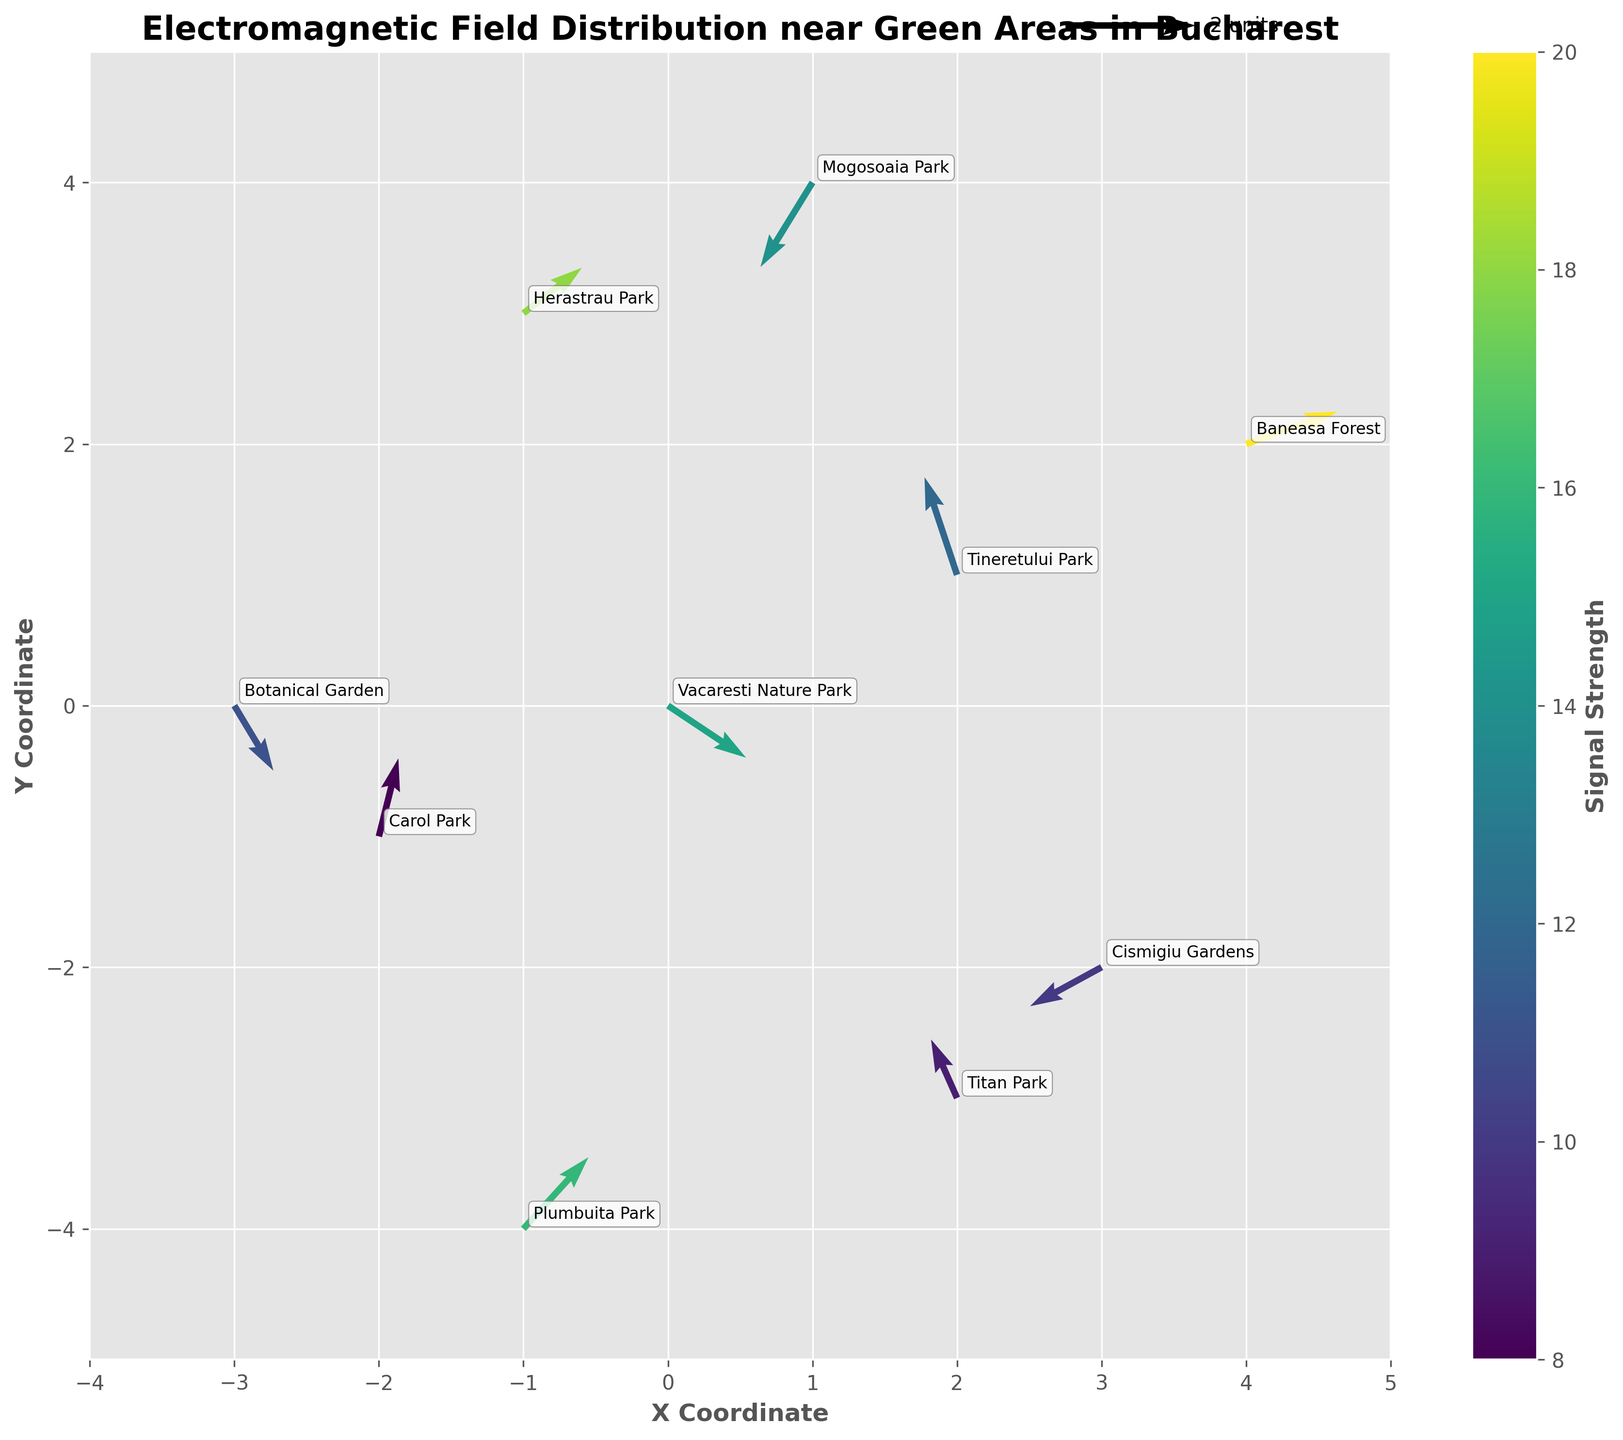Which area has the highest signal strength? By looking at the color shading of the arrows, we can identify the area with the highest signal strength. The color bar shows that a higher signal strength is indicated by a lighter color. The area with the highest signal strength is associated with the lightest yellow arrow.
Answer: Baneasa Forest What is the direction of the electromagnetic field in Tineretului Park? The electromagnetic field direction at Tineretului Park is determined by the arrow originating from its position. By observing, the arrow points approximately upwards and slightly to the right.
Answer: Up and slightly to the right Which two locations have arrows pointing in almost opposite directions? Arrows pointing in opposite directions will have angles that are approximately 180 degrees apart. By inspecting the plot, we can see that the arrows at Vacaresti Nature Park (pointing down-left) and Herastrau Park (pointing up-right) are nearly opposite.
Answer: Vacaresti Nature Park and Herastrau Park How does the signal strength of Titan Park compare to that of Carol Park? Comparing the colors of the arrows originating from Titan Park and Carol Park, Titan Park shows a slightly darker color than Carol Park. The color bar indicates that darker colors represent lower signal strength.
Answer: Titan Park has a lower signal strength than Carol Park Which coordinate has the strongest electromagnetic field pointing in the upward direction? To find the strongest electromagnetic field pointing upward, we look for the lightest colored arrow pointing upward. The plot shows this arrow at Herastrau Park.
Answer: Herastrau Park Is there any location where the electromagnetic field is pointing directly downward? An arrow pointing directly downward will be vertically aligned downward. Inspecting the plot reveals that there is no arrow pointing exactly downward.
Answer: No Which area has the weakest signal strength, and what is its electromagnetic field direction? By identifying the darkest colored arrow, we can find the area with the weakest signal strength. The area with the arrow located at Carol Park has the weakest signal strength, and its direction is almost upward.
Answer: Carol Park, upward What is the median signal strength among all the locations shown? To find the median signal strength, list the strengths in increasing order: 8, 9, 10, 11, 12, 14, 15, 16, 18, 20. The median is the average of the 5th and 6th values (12 + 14)/2.
Answer: 13 Which location has the electromagnetic field vector with the largest overall magnitude, and how is this determined? The magnitude of a vector is calculated as √(u² + v²). By comparing vectors, Baneasa Forest's vector (u=1.4, v=0.5) has the largest magnitude: √(1.4² + 0.5²) ≈ 1.5.
Answer: Baneasa Forest Which location on the plot has arrows with the smallest Euclidean length, and what might this suggest about its electromagnetic impact? The smallest Euclidean length of a vector suggests low impact. Calculating for the smallest vector, Carol Park's vector (u=0.3, v=1.2) has the smallest length: √(0.3² + 1.2²) ≈ 1.23.
Answer: Carol Park 